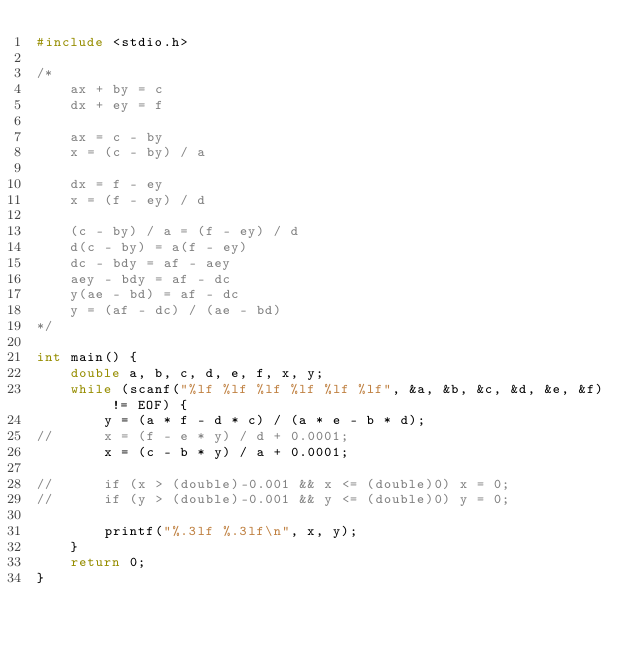<code> <loc_0><loc_0><loc_500><loc_500><_C_>#include <stdio.h>

/*
	ax + by = c
	dx + ey = f

	ax = c - by
	x = (c - by) / a

	dx = f - ey
	x = (f - ey) / d

	(c - by) / a = (f - ey) / d
	d(c - by) = a(f - ey)
	dc - bdy = af - aey
	aey - bdy = af - dc
	y(ae - bd) = af - dc
	y = (af - dc) / (ae - bd)
*/

int main() {
	double a, b, c, d, e, f, x, y;
	while (scanf("%lf %lf %lf %lf %lf %lf", &a, &b, &c, &d, &e, &f) != EOF) {
		y = (a * f - d * c) / (a * e - b * d);
//		x = (f - e * y) / d + 0.0001;
		x = (c - b * y) / a + 0.0001;

//		if (x > (double)-0.001 && x <= (double)0) x = 0;
//		if (y > (double)-0.001 && y <= (double)0) y = 0;

		printf("%.3lf %.3lf\n", x, y);
	}
	return 0;
}</code> 